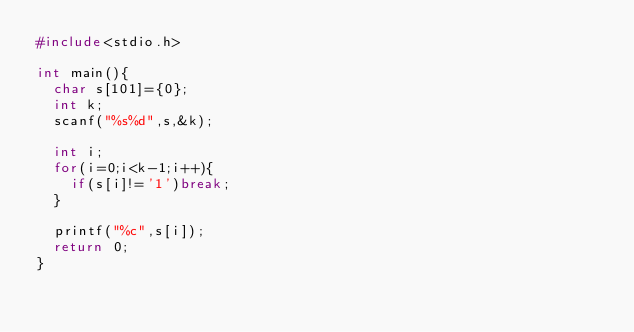Convert code to text. <code><loc_0><loc_0><loc_500><loc_500><_C_>#include<stdio.h>

int main(){
	char s[101]={0};
	int k;
	scanf("%s%d",s,&k);

	int i;
	for(i=0;i<k-1;i++){
		if(s[i]!='1')break;
	}

	printf("%c",s[i]);
	return 0;
}</code> 